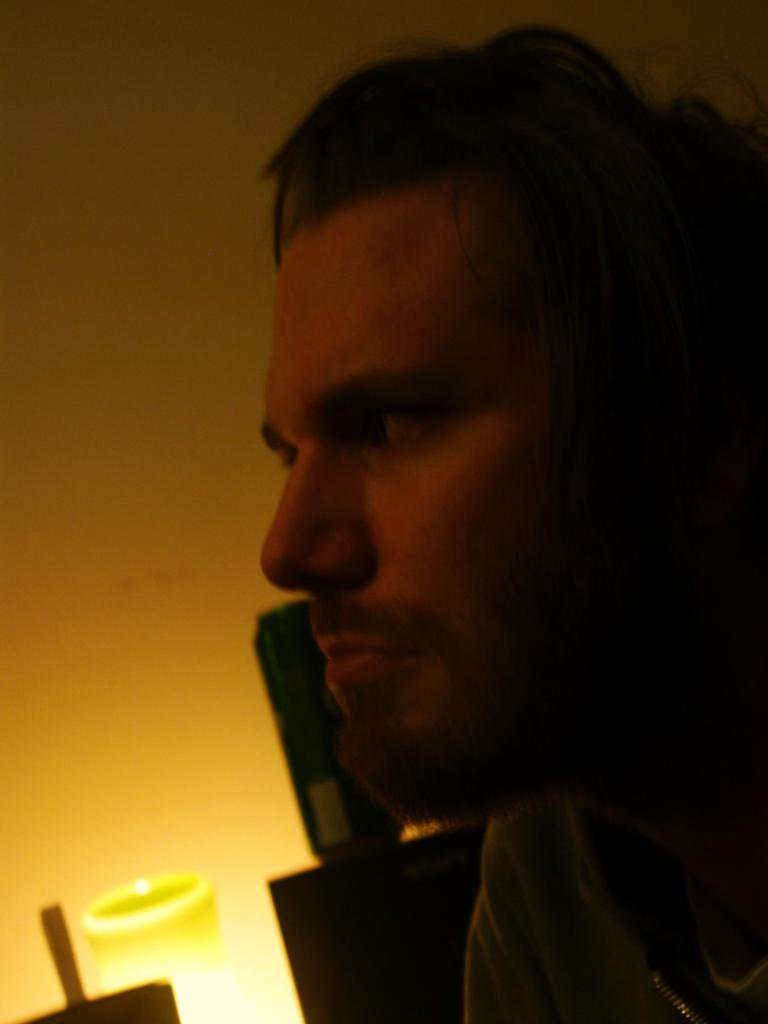What is the main subject of the image? There is a person in the image. What can be seen in the background of the image? There is a wall and other objects in the background of the image. What type of board is the person using to learn in the image? There is no board present in the image, and the person is not shown learning. 